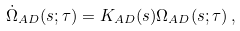Convert formula to latex. <formula><loc_0><loc_0><loc_500><loc_500>\dot { \Omega } _ { A D } ( s ; \tau ) = K _ { A D } ( s ) \Omega _ { A D } ( s ; \tau ) \, ,</formula> 